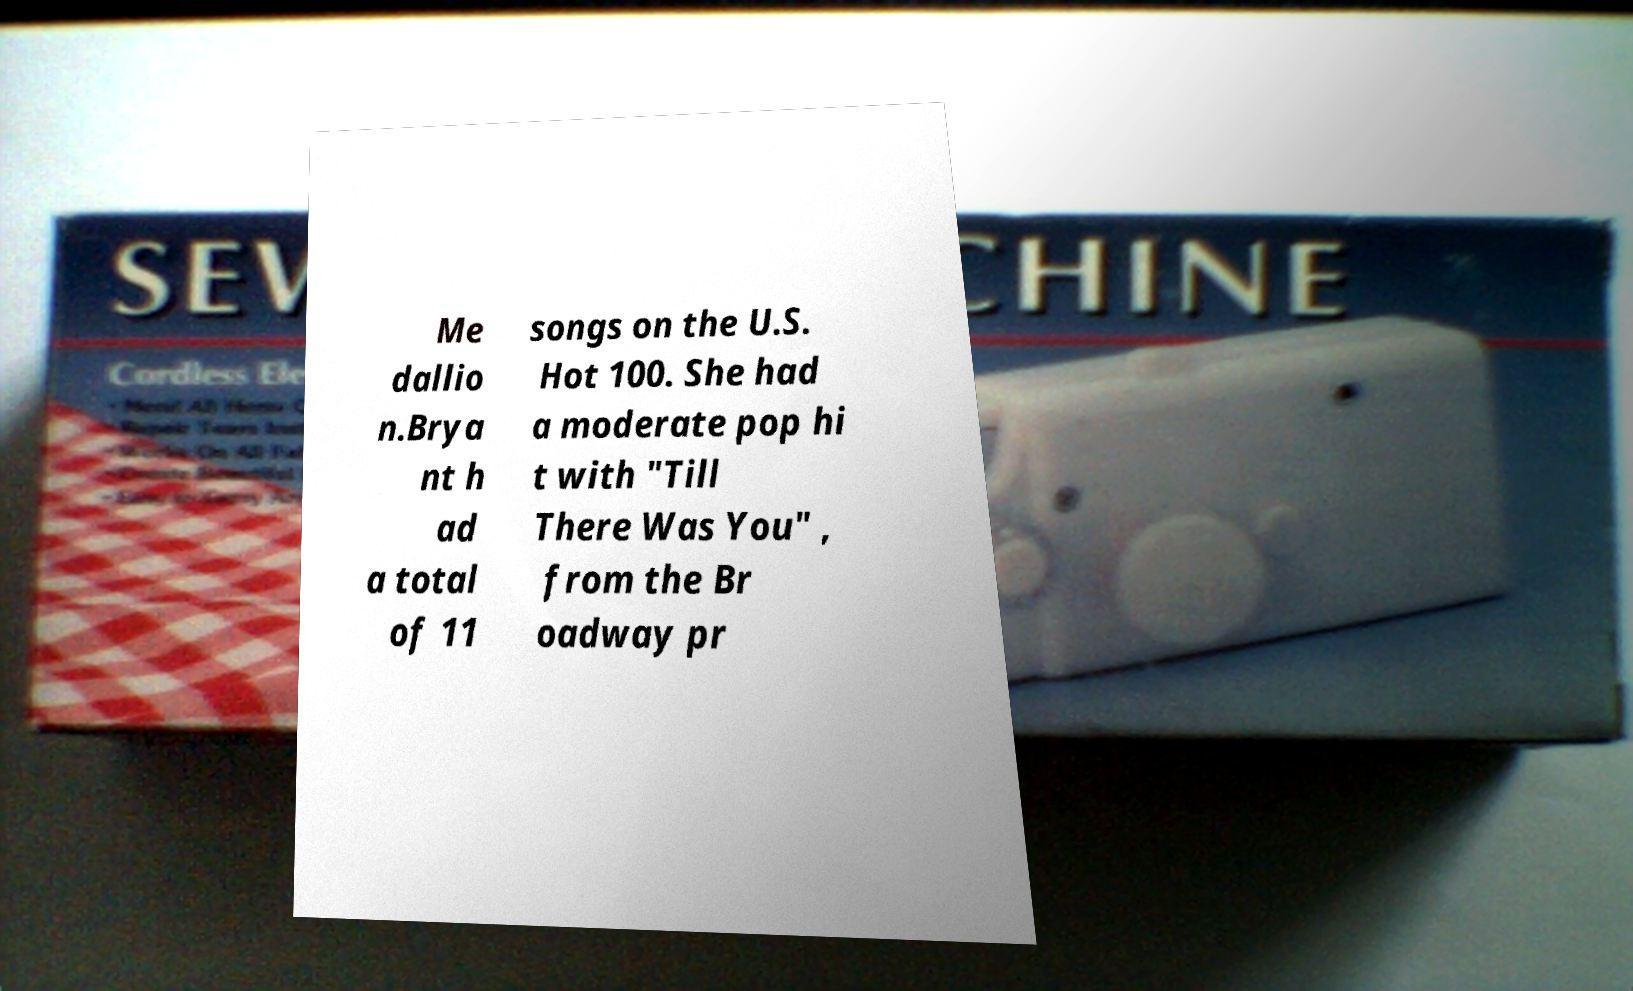I need the written content from this picture converted into text. Can you do that? Me dallio n.Brya nt h ad a total of 11 songs on the U.S. Hot 100. She had a moderate pop hi t with "Till There Was You" , from the Br oadway pr 